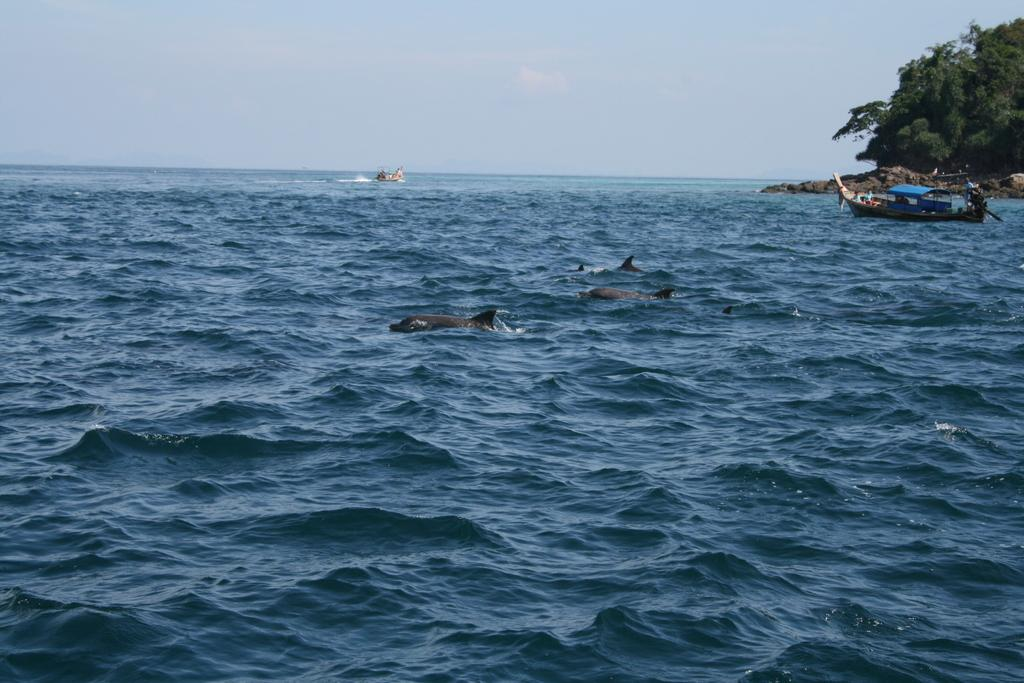What type of animals can be seen in the water in the image? There are fishes in the water in the image. What else can be seen in the image besides the fishes? There are boats, rocks, trees, and the sky visible in the image. Where are the rocks and trees located in the image? They are on the right side of the image. What is visible in the background of the image? The sky is visible in the background of the image, and there are clouds in the sky. What type of sticks can be seen in the image? There are no sticks present in the image. Are there any cherries visible in the image? There are no cherries present in the image. 